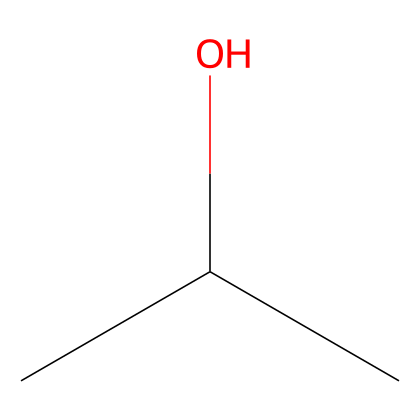What is the name of the chemical represented by this structure? The SMILES representation "CC(C)O" corresponds to isopropyl alcohol, which is a common name for the compound with this structure.
Answer: isopropyl alcohol How many carbon atoms are in the structure? By analyzing the SMILES, "CC(C)" indicates three carbon atoms: two from the "CC" and one from the branching "(C)."
Answer: three What functional group is present in isopropyl alcohol? The "O" in the SMILES indicates that there is a hydroxyl group (-OH), which is characteristic of alcohols.
Answer: hydroxyl Is isopropyl alcohol polar or nonpolar? The presence of the hydroxyl group (-OH) makes isopropyl alcohol polar due to its ability to form hydrogen bonds.
Answer: polar How many hydrogen atoms are in isopropyl alcohol's structure? Analyzing the structure, each carbon atom in this case has enough hydrogen atoms to satisfy the tetravalency: one carbon has three, and the others have two each, totaling eight.
Answer: eight What type of solvent is isopropyl alcohol classified as? Considering its properties, isopropyl alcohol is known for being a polar solvent, often used in various applications like first aid.
Answer: polar solvent 